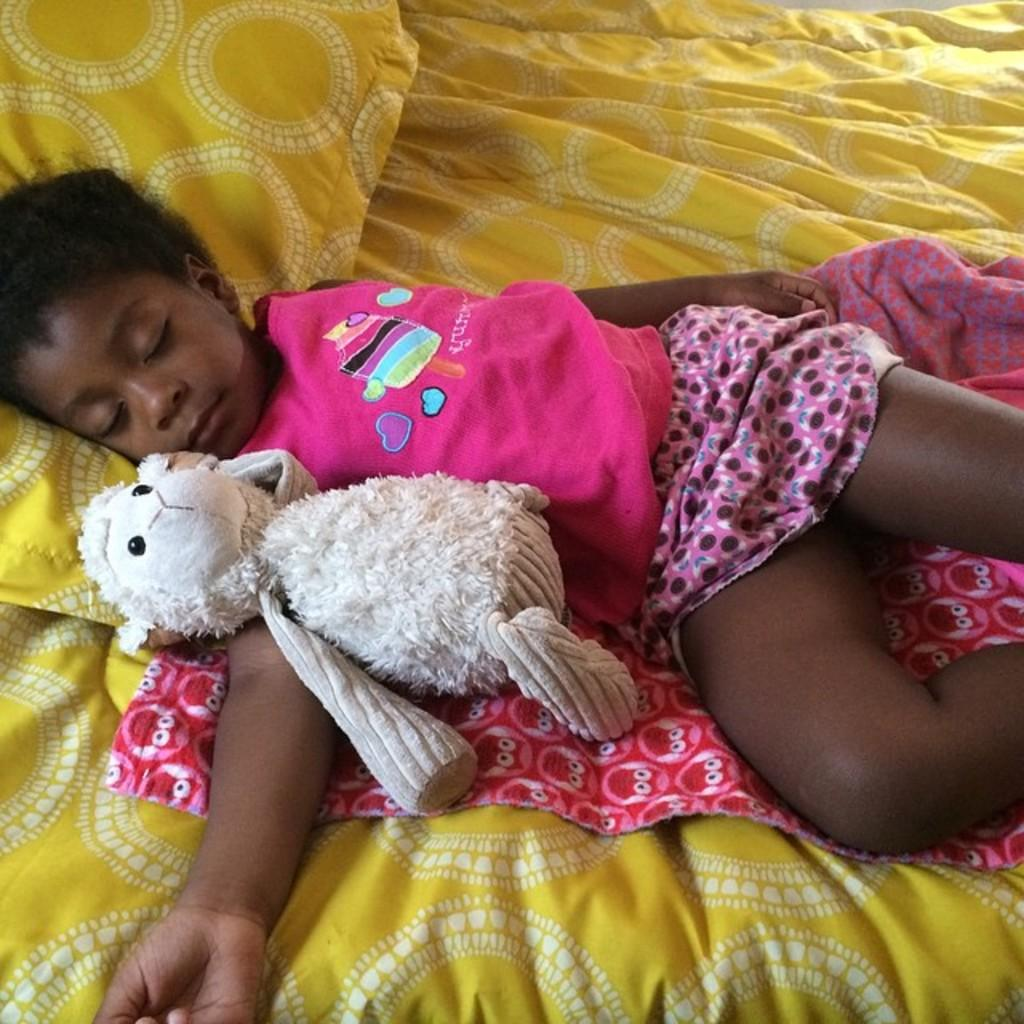What is the main subject of the image? There is a child in the image. What is the child doing in the image? The child is sleeping. Where is the child located in the image? The child is on a bed sheet. What type of material is visible in the image? There is cloth visible in the image. What other objects can be seen in the image? There is a toy and a pillow in the image. What type of wood is used to make the sugar in the image? There is no wood or sugar present in the image. 